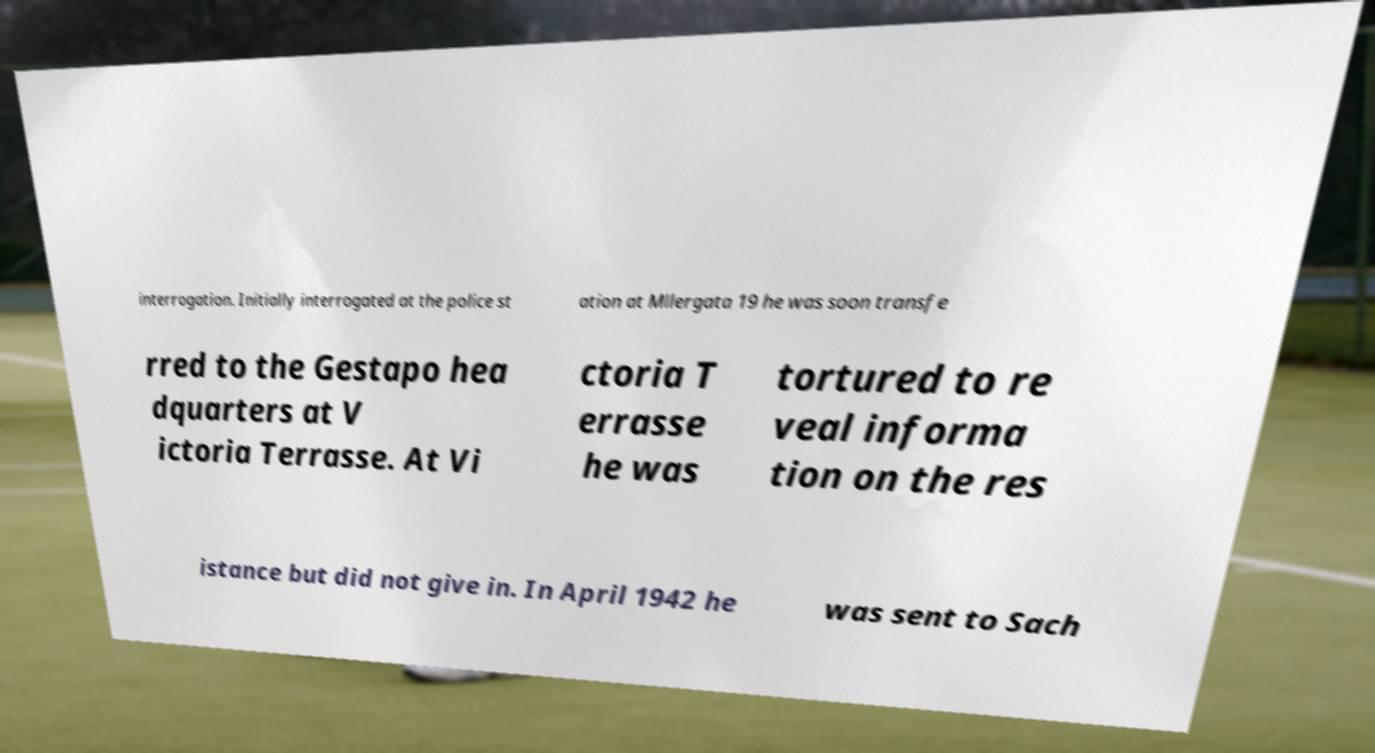Could you extract and type out the text from this image? interrogation. Initially interrogated at the police st ation at Mllergata 19 he was soon transfe rred to the Gestapo hea dquarters at V ictoria Terrasse. At Vi ctoria T errasse he was tortured to re veal informa tion on the res istance but did not give in. In April 1942 he was sent to Sach 